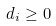<formula> <loc_0><loc_0><loc_500><loc_500>d _ { i } \geq 0</formula> 